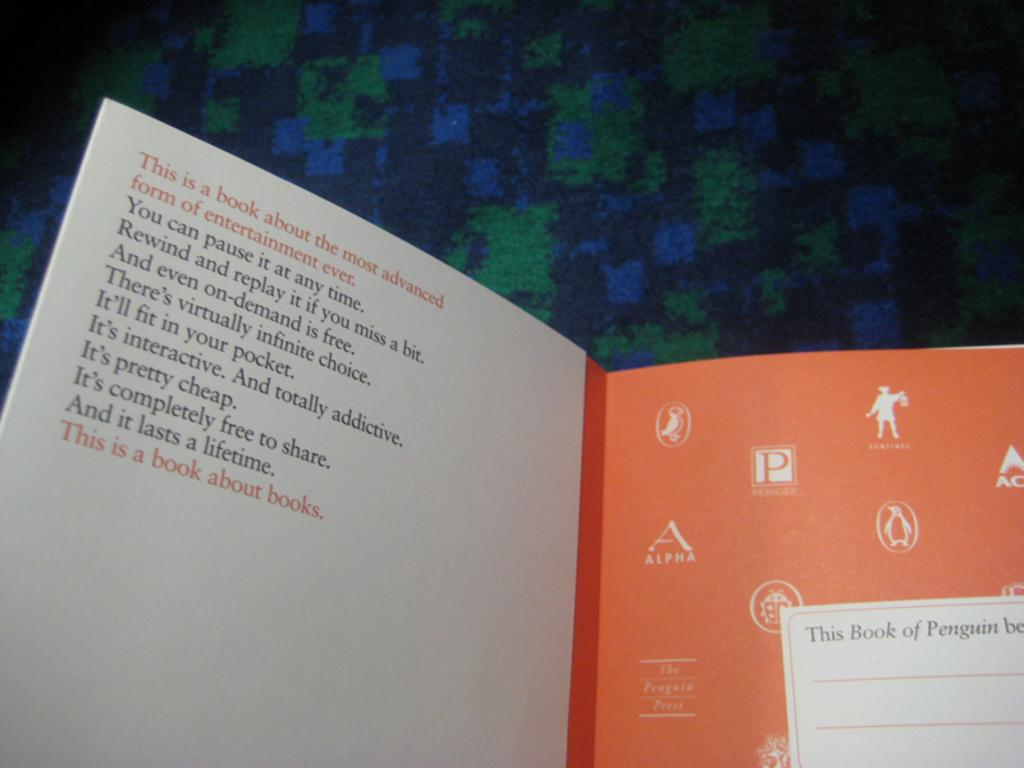<image>
Relay a brief, clear account of the picture shown. The book says it's a book about books and the inscription on the inside cover lists many of the benefits of reading. 